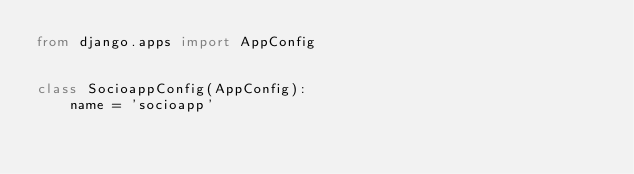Convert code to text. <code><loc_0><loc_0><loc_500><loc_500><_Python_>from django.apps import AppConfig


class SocioappConfig(AppConfig):
    name = 'socioapp'
</code> 